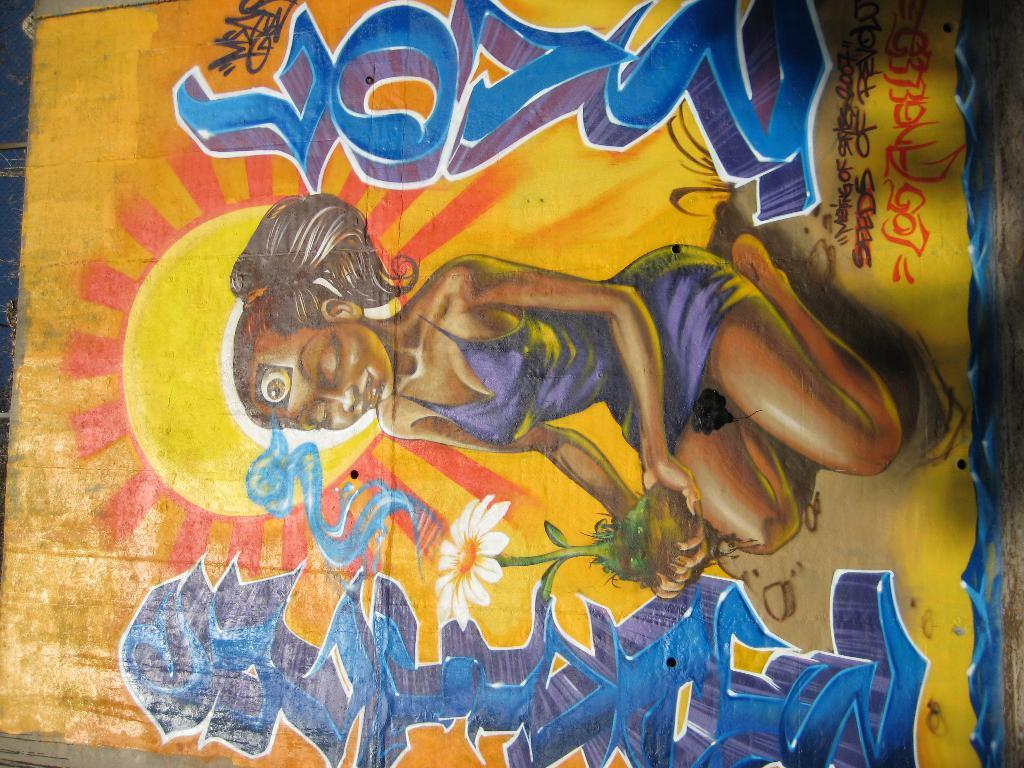What type of artwork is depicted in the image? The image is a painting. Can you describe the subject of the painting? There is a woman sitting in the painting. Are there any specific objects or elements in the painting? Yes, there is a white-colored flower in the painting. What is the profit margin of the flower in the painting? The painting is not a real-life scenario, so there is no profit margin associated with the flower. 